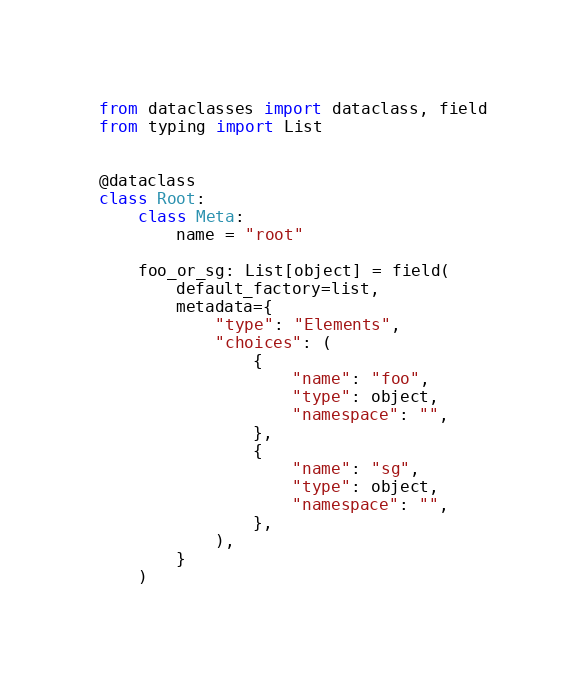Convert code to text. <code><loc_0><loc_0><loc_500><loc_500><_Python_>from dataclasses import dataclass, field
from typing import List


@dataclass
class Root:
    class Meta:
        name = "root"

    foo_or_sg: List[object] = field(
        default_factory=list,
        metadata={
            "type": "Elements",
            "choices": (
                {
                    "name": "foo",
                    "type": object,
                    "namespace": "",
                },
                {
                    "name": "sg",
                    "type": object,
                    "namespace": "",
                },
            ),
        }
    )
</code> 